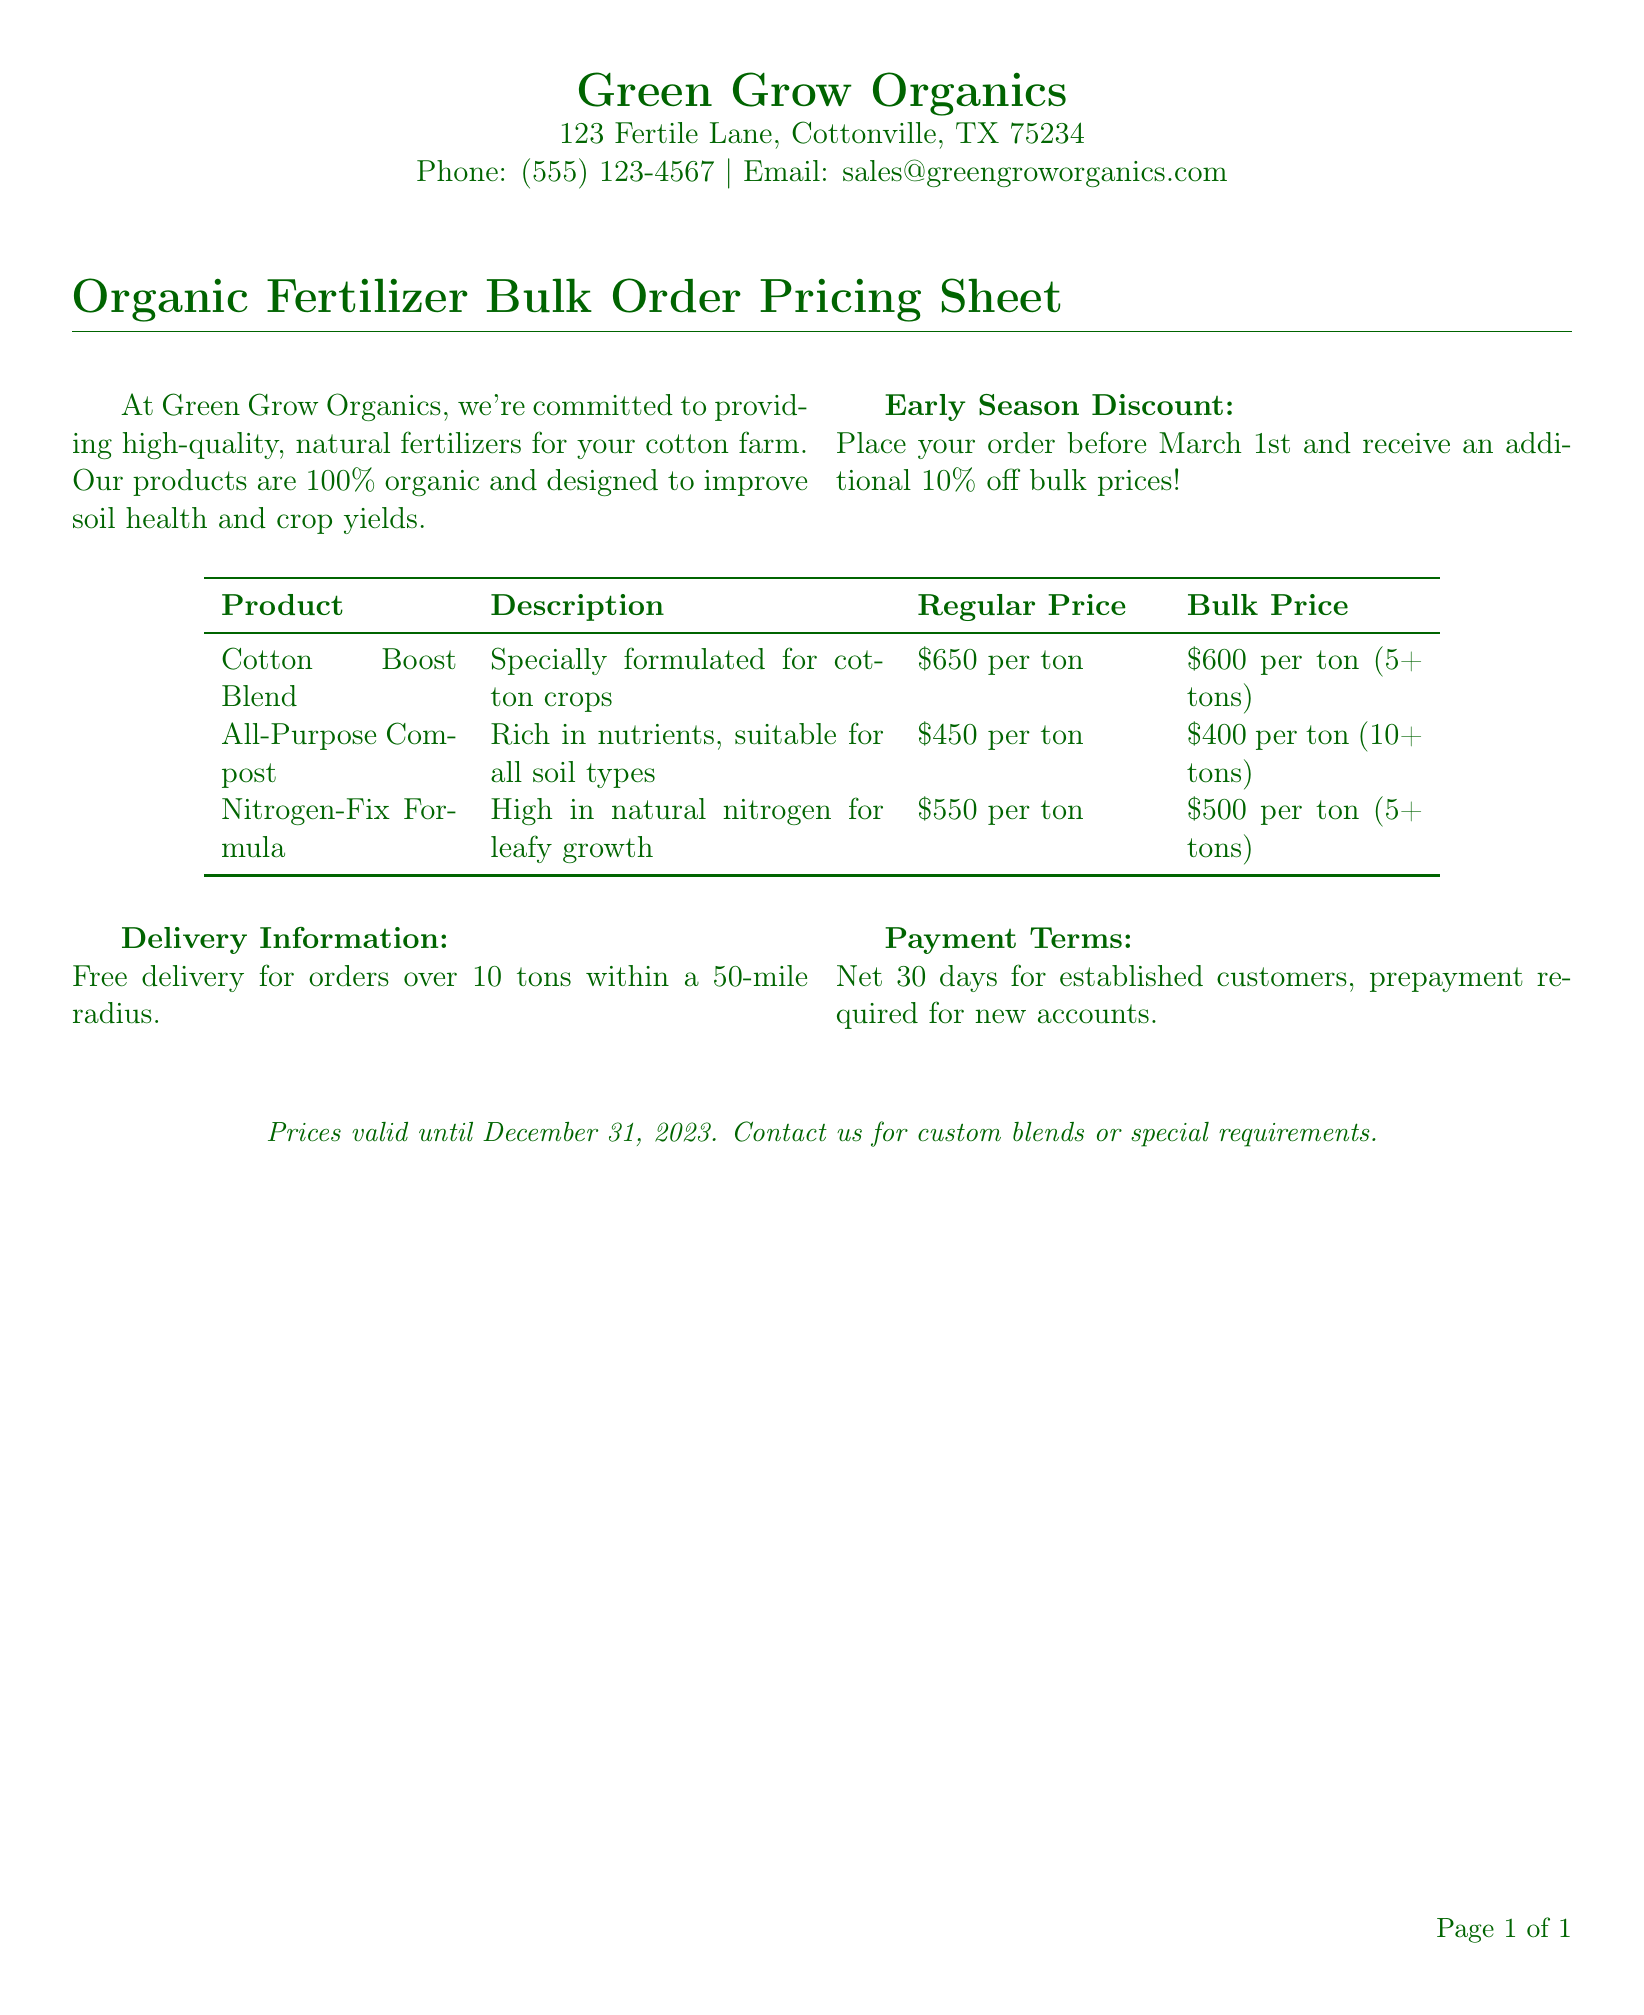What is the name of the company? The company name is presented at the top of the document.
Answer: Green Grow Organics What is the address of Green Grow Organics? The address is provided in the company contact information section.
Answer: 123 Fertile Lane, Cottonville, TX 75234 When is the early season discount deadline? The document specifies a date for the early season discount.
Answer: March 1st What is the bulk price for Cotton Boost Blend? The bulk price for Cotton Boost Blend is clearly listed in the pricing table.
Answer: $600 per ton (5+ tons) How much discount is offered for early season purchases? The discount percentage is stated in the early season discount section.
Answer: 10% What are the payment terms for new accounts? The payment terms for new accounts are mentioned in the payment terms section.
Answer: Prepayment required Is delivery free for orders under 10 tons? The document states conditions for free delivery in the delivery information section.
Answer: No What is the regular price for All-Purpose Compost? The regular price is provided in the pricing table for All-Purpose Compost.
Answer: $450 per ton What is the primary benefit of the Nitrogen-Fix Formula? The benefit is outlined in the description section for the product.
Answer: High in natural nitrogen for leafy growth 